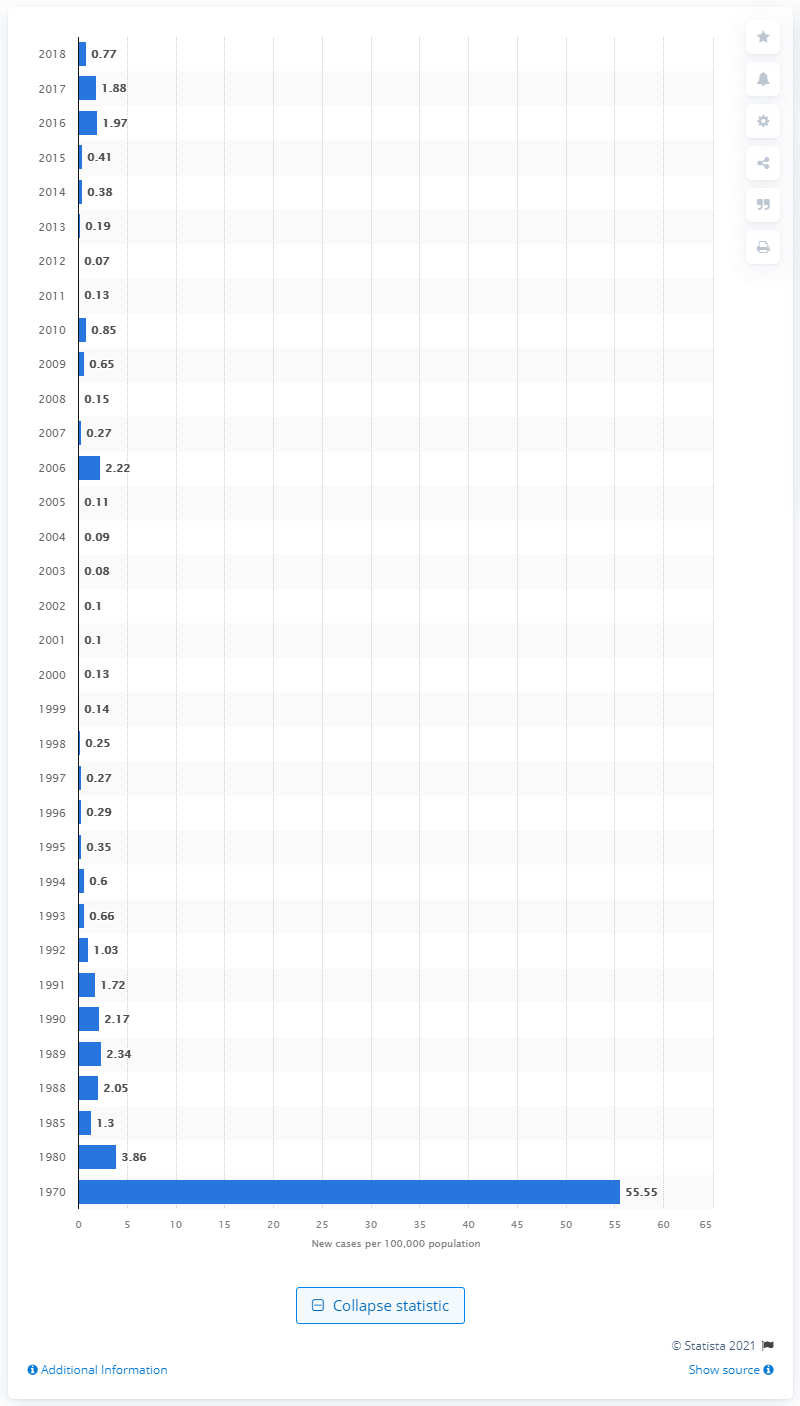Highlight a few significant elements in this photo. In 2018, there were 0.77 new cases of mumps per 100,000 inhabitants in the country. In 1970, there were approximately 55.55 new cases of mumps per 100,000 population. 